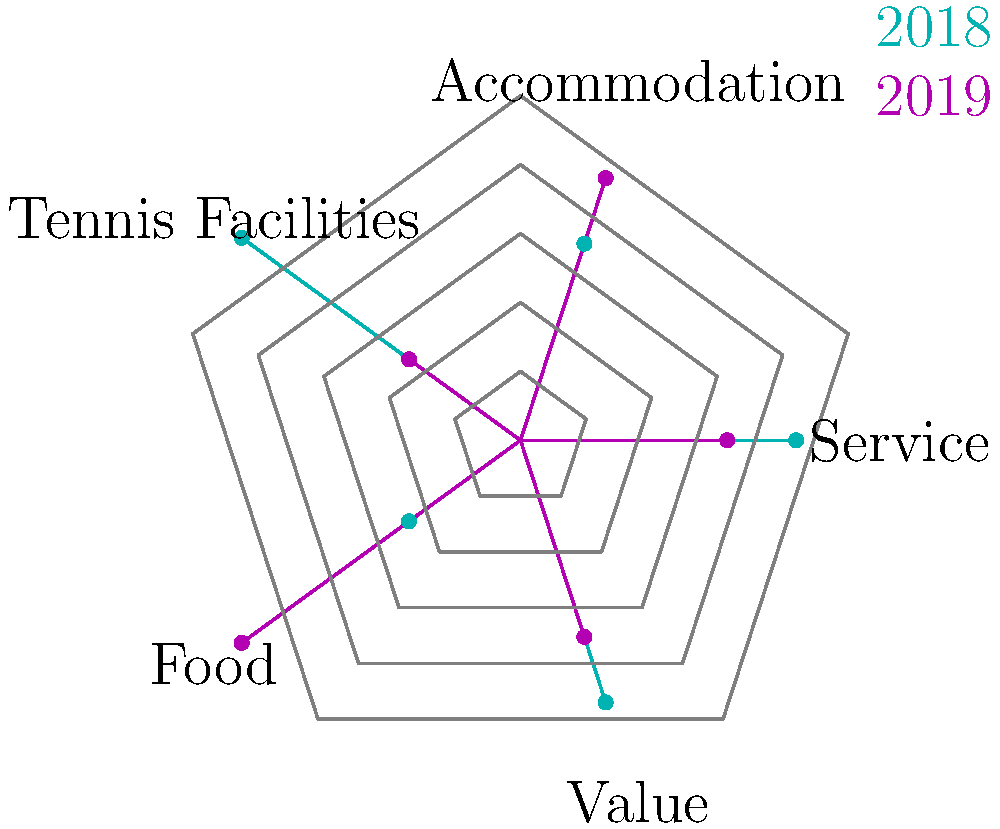Based on the radar chart comparing customer satisfaction scores for tennis-themed vacations in 2018 and 2019, which aspect showed the most significant improvement from 2018 to 2019? To determine which aspect showed the most significant improvement from 2018 to 2019, we need to compare the scores for each aspect between the two years:

1. Service: 2018 score = 4, 2019 score = 3
   Change: -1 (decreased)

2. Accommodation: 2018 score = 3, 2019 score = 4
   Change: +1 (improved)

3. Tennis Facilities: 2018 score = 5, 2019 score = 2
   Change: -3 (decreased)

4. Food: 2018 score = 2, 2019 score = 5
   Change: +3 (improved)

5. Value: 2018 score = 4, 2019 score = 3
   Change: -1 (decreased)

The aspect with the largest positive change from 2018 to 2019 is Food, with an improvement of 3 points.
Answer: Food 